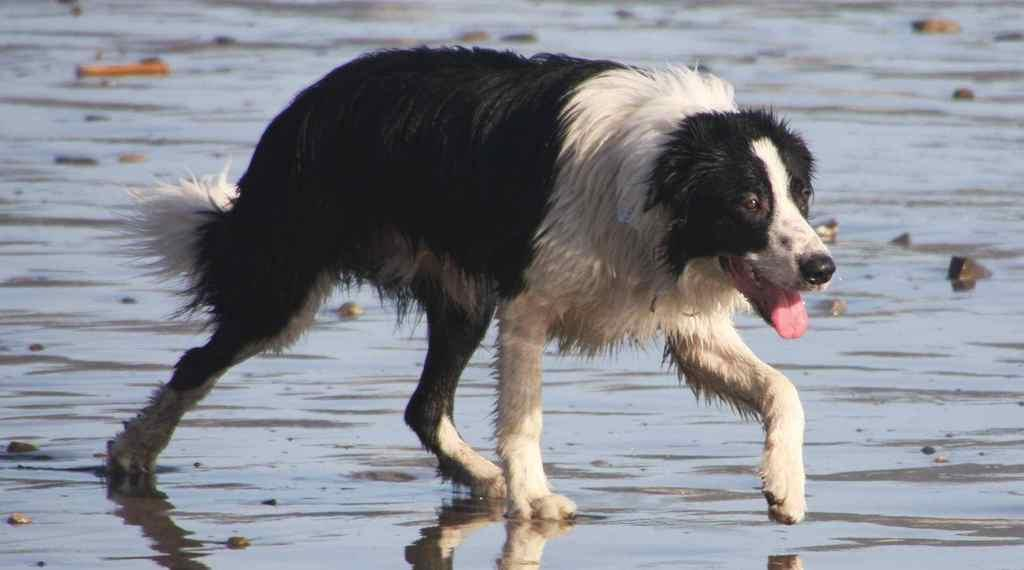What animal can be seen in the image? There is a dog in the image. What is the dog doing in the image? The dog is walking in the water. What type of terrain is visible in the image? There are stones visible in the image. What can be inferred about the weather on the day the image was taken? The image was likely taken on a sunny day. How many slaves are present in the image? There are no slaves present in the image; it features a dog walking in the water. Is the image particularly quiet or noisy? The image itself is neither quiet nor noisy, as it is a still image and does not contain any sound. 